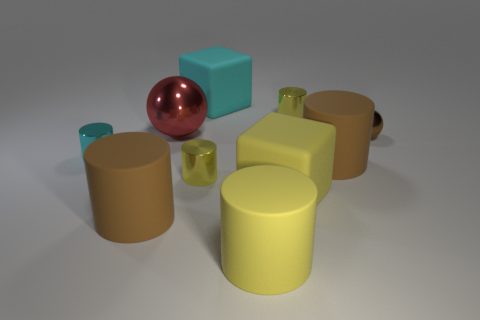Do the large cyan matte object and the tiny cyan thing have the same shape?
Give a very brief answer. No. Are there any brown objects that have the same shape as the small cyan thing?
Provide a short and direct response. Yes. What is the shape of the brown thing that is the same size as the cyan metal object?
Provide a short and direct response. Sphere. There is a big object that is on the right side of the yellow cylinder that is behind the brown metal thing in front of the red thing; what is it made of?
Your answer should be very brief. Rubber. Is the size of the yellow matte cylinder the same as the red shiny object?
Provide a short and direct response. Yes. What is the material of the big yellow cylinder?
Make the answer very short. Rubber. There is a tiny yellow metal object that is to the left of the big cyan thing; does it have the same shape as the big cyan thing?
Your answer should be very brief. No. What number of things are either big yellow rubber objects or shiny cylinders?
Provide a short and direct response. 5. Do the small cylinder in front of the cyan cylinder and the large red thing have the same material?
Provide a succinct answer. Yes. What size is the red object?
Provide a short and direct response. Large. 